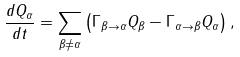Convert formula to latex. <formula><loc_0><loc_0><loc_500><loc_500>\frac { d Q _ { \alpha } } { d t } = \sum _ { { \beta } \neq \alpha } \left ( \Gamma _ { { \beta } \to { \alpha } } Q _ { \beta } - \Gamma _ { { \alpha } \to { \beta } } Q _ { \alpha } \right ) ,</formula> 